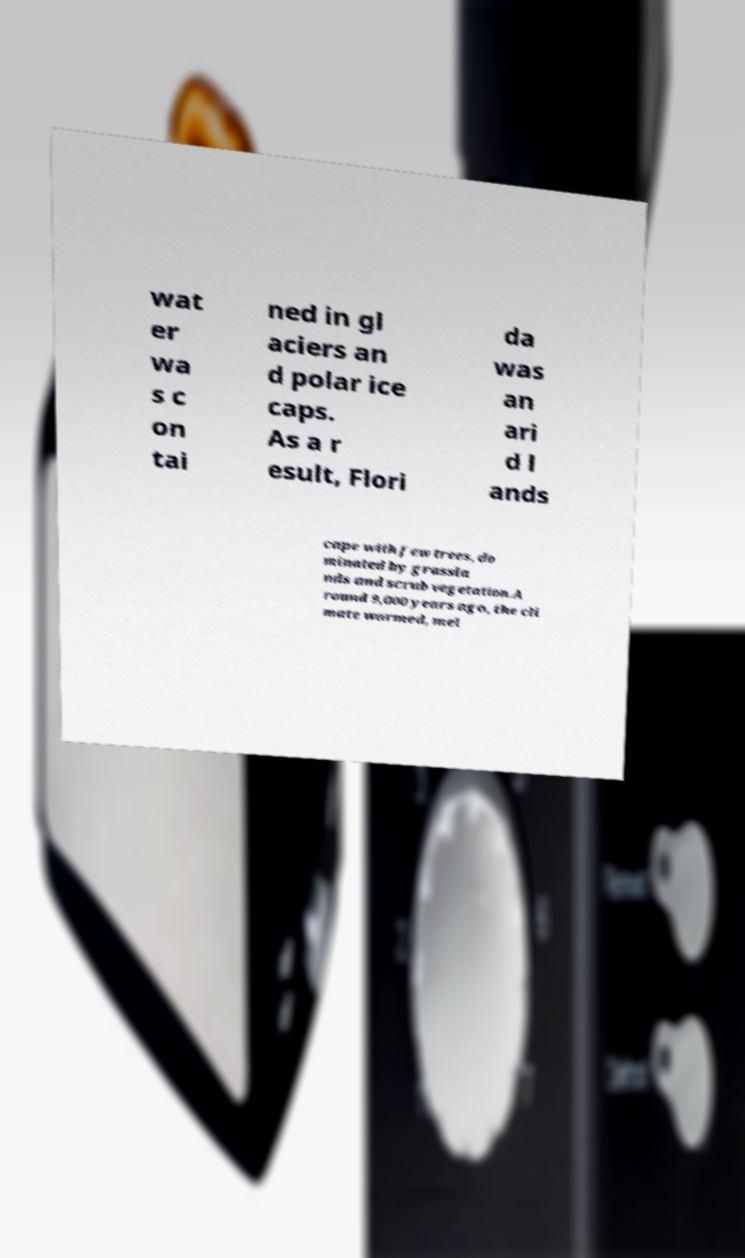Could you assist in decoding the text presented in this image and type it out clearly? wat er wa s c on tai ned in gl aciers an d polar ice caps. As a r esult, Flori da was an ari d l ands cape with few trees, do minated by grassla nds and scrub vegetation.A round 9,000 years ago, the cli mate warmed, mel 